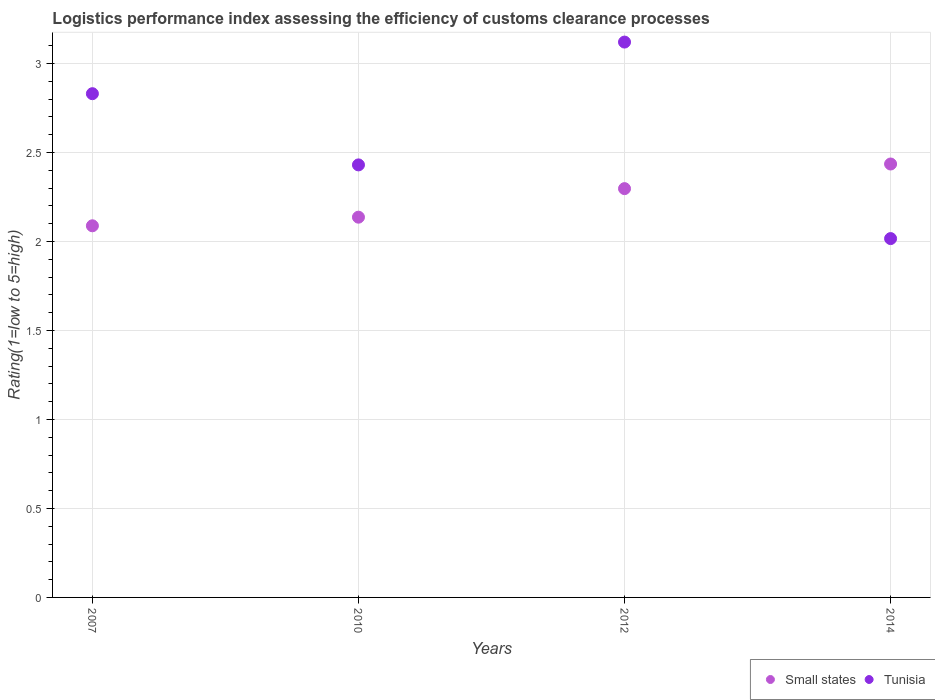What is the Logistic performance index in Small states in 2014?
Provide a short and direct response. 2.43. Across all years, what is the maximum Logistic performance index in Tunisia?
Ensure brevity in your answer.  3.12. Across all years, what is the minimum Logistic performance index in Tunisia?
Provide a short and direct response. 2.02. In which year was the Logistic performance index in Tunisia minimum?
Provide a succinct answer. 2014. What is the total Logistic performance index in Small states in the graph?
Offer a terse response. 8.96. What is the difference between the Logistic performance index in Small states in 2012 and that in 2014?
Provide a succinct answer. -0.14. What is the difference between the Logistic performance index in Tunisia in 2007 and the Logistic performance index in Small states in 2012?
Your response must be concise. 0.53. What is the average Logistic performance index in Tunisia per year?
Provide a succinct answer. 2.6. In the year 2010, what is the difference between the Logistic performance index in Small states and Logistic performance index in Tunisia?
Offer a terse response. -0.29. What is the ratio of the Logistic performance index in Tunisia in 2007 to that in 2010?
Ensure brevity in your answer.  1.16. Is the Logistic performance index in Tunisia in 2010 less than that in 2014?
Give a very brief answer. No. Is the difference between the Logistic performance index in Small states in 2007 and 2012 greater than the difference between the Logistic performance index in Tunisia in 2007 and 2012?
Offer a terse response. Yes. What is the difference between the highest and the second highest Logistic performance index in Tunisia?
Offer a terse response. 0.29. What is the difference between the highest and the lowest Logistic performance index in Tunisia?
Provide a succinct answer. 1.1. In how many years, is the Logistic performance index in Small states greater than the average Logistic performance index in Small states taken over all years?
Provide a short and direct response. 2. Is the Logistic performance index in Small states strictly greater than the Logistic performance index in Tunisia over the years?
Provide a succinct answer. No. Is the Logistic performance index in Tunisia strictly less than the Logistic performance index in Small states over the years?
Give a very brief answer. No. How many dotlines are there?
Give a very brief answer. 2. How many years are there in the graph?
Your answer should be very brief. 4. What is the difference between two consecutive major ticks on the Y-axis?
Your response must be concise. 0.5. Does the graph contain grids?
Your answer should be very brief. Yes. Where does the legend appear in the graph?
Offer a terse response. Bottom right. What is the title of the graph?
Your answer should be very brief. Logistics performance index assessing the efficiency of customs clearance processes. What is the label or title of the Y-axis?
Ensure brevity in your answer.  Rating(1=low to 5=high). What is the Rating(1=low to 5=high) of Small states in 2007?
Give a very brief answer. 2.09. What is the Rating(1=low to 5=high) in Tunisia in 2007?
Provide a short and direct response. 2.83. What is the Rating(1=low to 5=high) in Small states in 2010?
Ensure brevity in your answer.  2.14. What is the Rating(1=low to 5=high) of Tunisia in 2010?
Give a very brief answer. 2.43. What is the Rating(1=low to 5=high) of Small states in 2012?
Offer a very short reply. 2.3. What is the Rating(1=low to 5=high) in Tunisia in 2012?
Provide a short and direct response. 3.12. What is the Rating(1=low to 5=high) in Small states in 2014?
Keep it short and to the point. 2.43. What is the Rating(1=low to 5=high) in Tunisia in 2014?
Keep it short and to the point. 2.02. Across all years, what is the maximum Rating(1=low to 5=high) of Small states?
Your response must be concise. 2.43. Across all years, what is the maximum Rating(1=low to 5=high) of Tunisia?
Keep it short and to the point. 3.12. Across all years, what is the minimum Rating(1=low to 5=high) of Small states?
Keep it short and to the point. 2.09. Across all years, what is the minimum Rating(1=low to 5=high) of Tunisia?
Your answer should be compact. 2.02. What is the total Rating(1=low to 5=high) in Small states in the graph?
Your response must be concise. 8.96. What is the total Rating(1=low to 5=high) in Tunisia in the graph?
Provide a succinct answer. 10.4. What is the difference between the Rating(1=low to 5=high) of Small states in 2007 and that in 2010?
Give a very brief answer. -0.05. What is the difference between the Rating(1=low to 5=high) in Small states in 2007 and that in 2012?
Your answer should be compact. -0.21. What is the difference between the Rating(1=low to 5=high) in Tunisia in 2007 and that in 2012?
Offer a terse response. -0.29. What is the difference between the Rating(1=low to 5=high) in Small states in 2007 and that in 2014?
Offer a terse response. -0.35. What is the difference between the Rating(1=low to 5=high) of Tunisia in 2007 and that in 2014?
Your answer should be very brief. 0.81. What is the difference between the Rating(1=low to 5=high) of Small states in 2010 and that in 2012?
Ensure brevity in your answer.  -0.16. What is the difference between the Rating(1=low to 5=high) of Tunisia in 2010 and that in 2012?
Offer a very short reply. -0.69. What is the difference between the Rating(1=low to 5=high) of Small states in 2010 and that in 2014?
Provide a short and direct response. -0.3. What is the difference between the Rating(1=low to 5=high) in Tunisia in 2010 and that in 2014?
Give a very brief answer. 0.41. What is the difference between the Rating(1=low to 5=high) of Small states in 2012 and that in 2014?
Your answer should be compact. -0.14. What is the difference between the Rating(1=low to 5=high) in Tunisia in 2012 and that in 2014?
Keep it short and to the point. 1.1. What is the difference between the Rating(1=low to 5=high) in Small states in 2007 and the Rating(1=low to 5=high) in Tunisia in 2010?
Offer a terse response. -0.34. What is the difference between the Rating(1=low to 5=high) of Small states in 2007 and the Rating(1=low to 5=high) of Tunisia in 2012?
Your response must be concise. -1.03. What is the difference between the Rating(1=low to 5=high) of Small states in 2007 and the Rating(1=low to 5=high) of Tunisia in 2014?
Your answer should be compact. 0.07. What is the difference between the Rating(1=low to 5=high) of Small states in 2010 and the Rating(1=low to 5=high) of Tunisia in 2012?
Make the answer very short. -0.98. What is the difference between the Rating(1=low to 5=high) in Small states in 2010 and the Rating(1=low to 5=high) in Tunisia in 2014?
Ensure brevity in your answer.  0.12. What is the difference between the Rating(1=low to 5=high) in Small states in 2012 and the Rating(1=low to 5=high) in Tunisia in 2014?
Provide a succinct answer. 0.28. What is the average Rating(1=low to 5=high) of Small states per year?
Offer a very short reply. 2.24. What is the average Rating(1=low to 5=high) of Tunisia per year?
Your answer should be compact. 2.6. In the year 2007, what is the difference between the Rating(1=low to 5=high) in Small states and Rating(1=low to 5=high) in Tunisia?
Make the answer very short. -0.74. In the year 2010, what is the difference between the Rating(1=low to 5=high) in Small states and Rating(1=low to 5=high) in Tunisia?
Your response must be concise. -0.29. In the year 2012, what is the difference between the Rating(1=low to 5=high) of Small states and Rating(1=low to 5=high) of Tunisia?
Give a very brief answer. -0.82. In the year 2014, what is the difference between the Rating(1=low to 5=high) in Small states and Rating(1=low to 5=high) in Tunisia?
Offer a terse response. 0.42. What is the ratio of the Rating(1=low to 5=high) of Small states in 2007 to that in 2010?
Provide a short and direct response. 0.98. What is the ratio of the Rating(1=low to 5=high) of Tunisia in 2007 to that in 2010?
Offer a terse response. 1.16. What is the ratio of the Rating(1=low to 5=high) in Tunisia in 2007 to that in 2012?
Your answer should be very brief. 0.91. What is the ratio of the Rating(1=low to 5=high) of Small states in 2007 to that in 2014?
Give a very brief answer. 0.86. What is the ratio of the Rating(1=low to 5=high) of Tunisia in 2007 to that in 2014?
Your response must be concise. 1.4. What is the ratio of the Rating(1=low to 5=high) of Small states in 2010 to that in 2012?
Provide a short and direct response. 0.93. What is the ratio of the Rating(1=low to 5=high) of Tunisia in 2010 to that in 2012?
Your answer should be very brief. 0.78. What is the ratio of the Rating(1=low to 5=high) in Small states in 2010 to that in 2014?
Offer a very short reply. 0.88. What is the ratio of the Rating(1=low to 5=high) of Tunisia in 2010 to that in 2014?
Give a very brief answer. 1.21. What is the ratio of the Rating(1=low to 5=high) of Small states in 2012 to that in 2014?
Your answer should be very brief. 0.94. What is the ratio of the Rating(1=low to 5=high) in Tunisia in 2012 to that in 2014?
Your answer should be very brief. 1.55. What is the difference between the highest and the second highest Rating(1=low to 5=high) in Small states?
Your response must be concise. 0.14. What is the difference between the highest and the second highest Rating(1=low to 5=high) in Tunisia?
Offer a very short reply. 0.29. What is the difference between the highest and the lowest Rating(1=low to 5=high) in Small states?
Your answer should be very brief. 0.35. What is the difference between the highest and the lowest Rating(1=low to 5=high) in Tunisia?
Keep it short and to the point. 1.1. 